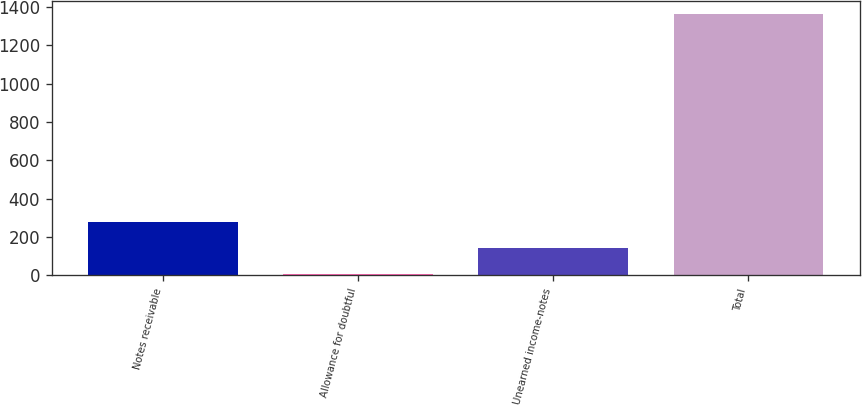<chart> <loc_0><loc_0><loc_500><loc_500><bar_chart><fcel>Notes receivable<fcel>Allowance for doubtful<fcel>Unearned income-notes<fcel>Total<nl><fcel>277.52<fcel>5.7<fcel>141.61<fcel>1364.8<nl></chart> 